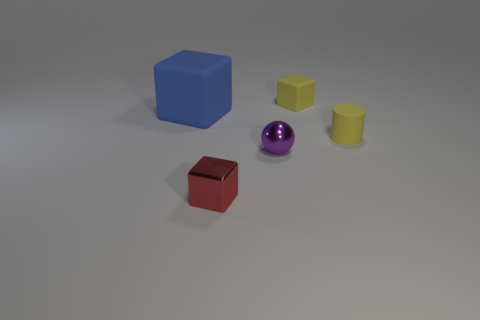Is there an object that stands out from the others due to its texture or color? Yes, the spherical purple object stands out with its shiny texture and distinct color, setting it apart from the other matte-finished items. 